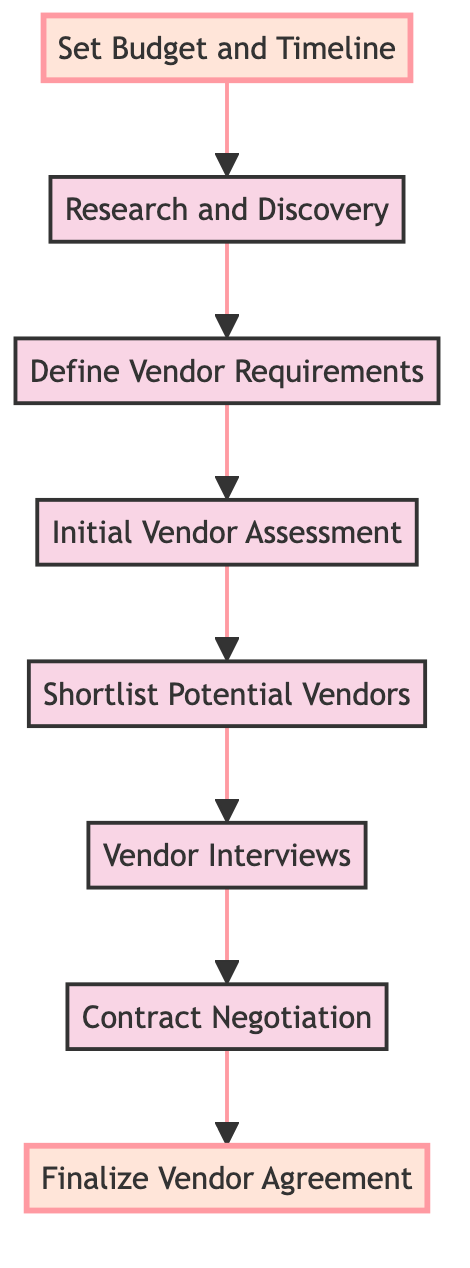What is the first step in the workflow? The first step in the workflow as represented at the bottom of the diagram is "Set Budget and Timeline."
Answer: Set Budget and Timeline How many steps are in the flow? There are a total of 8 steps represented in the flowchart from the bottom to the top.
Answer: 8 What are the last two steps in the vendor selection workflow? The last two steps before finalizing the agreement are "Contract Negotiation" and "Finalize Vendor Agreement."
Answer: Contract Negotiation, Finalize Vendor Agreement What connects “Shortlist Potential Vendors” and “Vendor Interviews”? "Shortlist Potential Vendors" leads directly to "Vendor Interviews," making it a connection through a single arrow.
Answer: Vendor Interviews Which step involves evaluating vendors based on reputation and experience? The step that involves evaluating vendors based on reputation and experience is "Initial Vendor Assessment."
Answer: Initial Vendor Assessment What is the relationship between "Define Vendor Requirements" and "Initial Vendor Assessment"? "Define Vendor Requirements" directly leads to "Initial Vendor Assessment," meaning it is a prerequisite step in the workflow.
Answer: Prerequisite In the workflow, how does one move from "Research and Discovery" to "Define Vendor Requirements"? One moves from "Research and Discovery" to "Define Vendor Requirements" through a direct connection that follows the sequence of actions in the flowchart.
Answer: Direct connection What step follows "Vendor Interviews"? The step that follows "Vendor Interviews" is "Contract Negotiation."
Answer: Contract Negotiation 